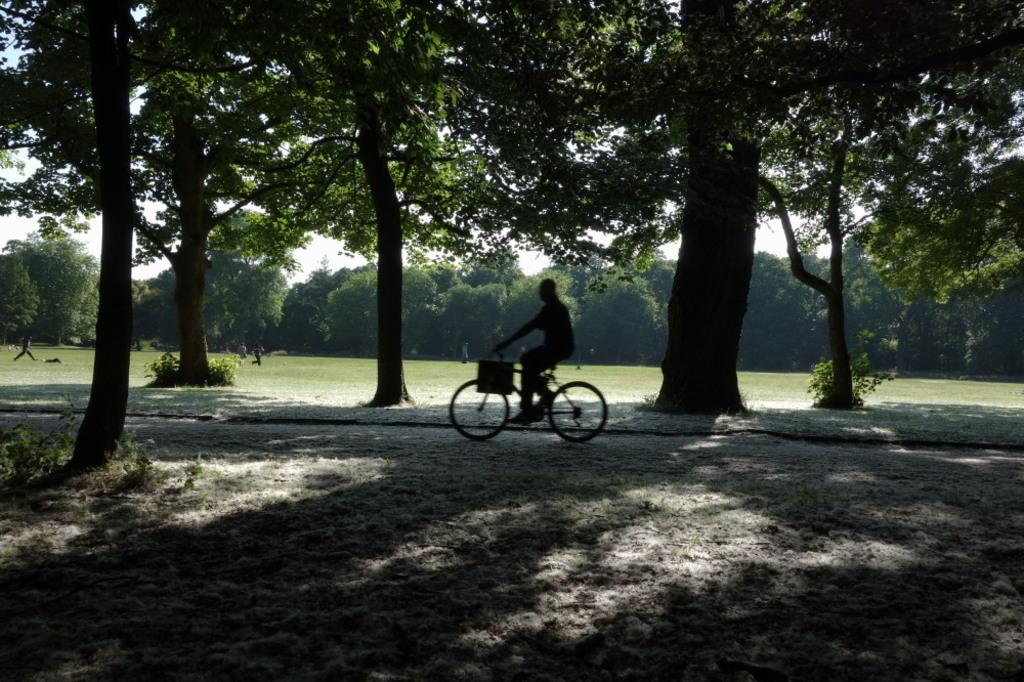What is the main subject of the image? There is a person riding a bicycle in the image. What can be seen in the background of the image? There are trees and people visible in the background of the image. What is the color of the sky in the image? The sky appears to be white in color. Can you see a table with a lamp on it in the image? There is no table or lamp present in the image. 